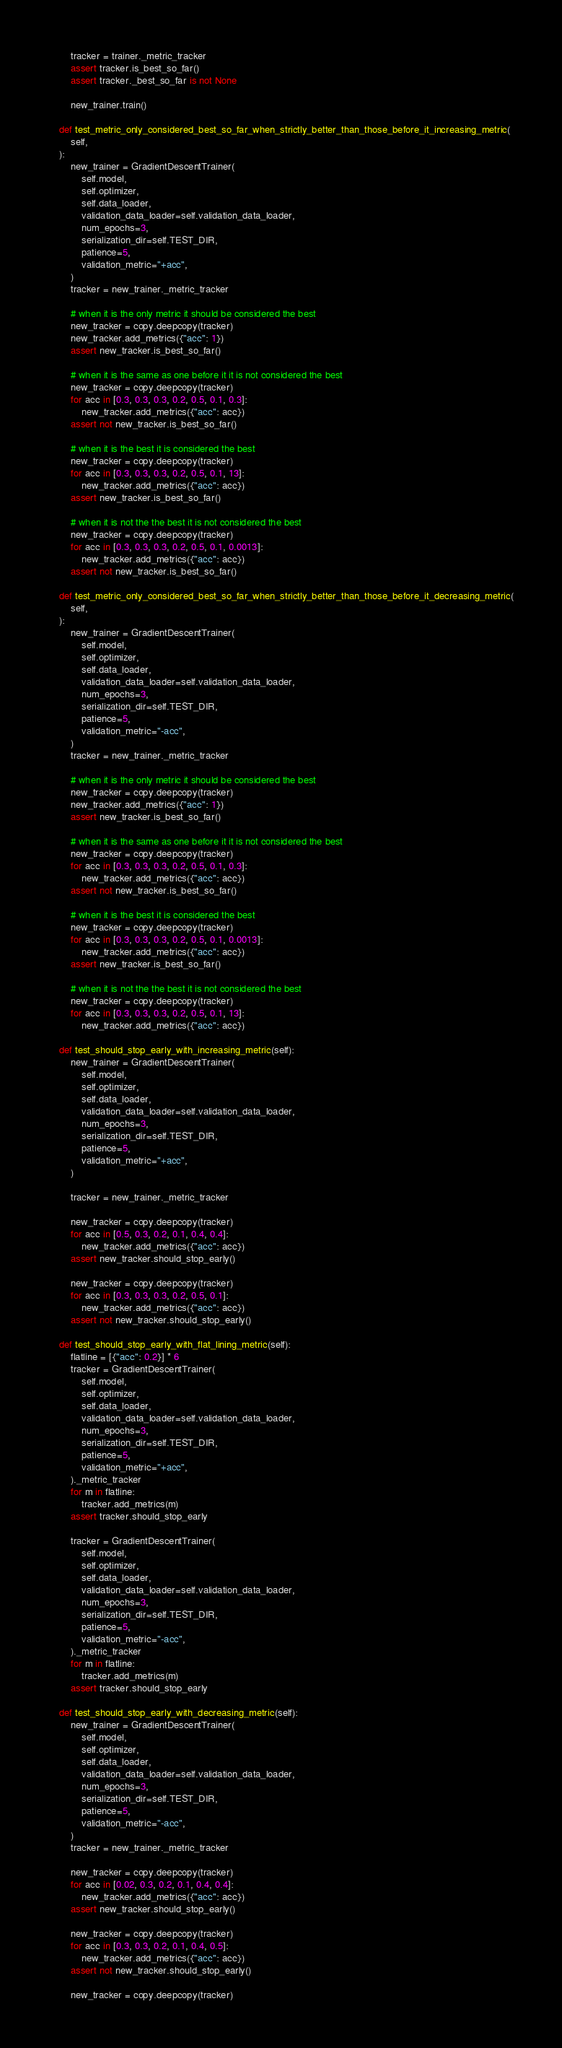Convert code to text. <code><loc_0><loc_0><loc_500><loc_500><_Python_>        tracker = trainer._metric_tracker
        assert tracker.is_best_so_far()
        assert tracker._best_so_far is not None

        new_trainer.train()

    def test_metric_only_considered_best_so_far_when_strictly_better_than_those_before_it_increasing_metric(
        self,
    ):
        new_trainer = GradientDescentTrainer(
            self.model,
            self.optimizer,
            self.data_loader,
            validation_data_loader=self.validation_data_loader,
            num_epochs=3,
            serialization_dir=self.TEST_DIR,
            patience=5,
            validation_metric="+acc",
        )
        tracker = new_trainer._metric_tracker

        # when it is the only metric it should be considered the best
        new_tracker = copy.deepcopy(tracker)
        new_tracker.add_metrics({"acc": 1})
        assert new_tracker.is_best_so_far()

        # when it is the same as one before it it is not considered the best
        new_tracker = copy.deepcopy(tracker)
        for acc in [0.3, 0.3, 0.3, 0.2, 0.5, 0.1, 0.3]:
            new_tracker.add_metrics({"acc": acc})
        assert not new_tracker.is_best_so_far()

        # when it is the best it is considered the best
        new_tracker = copy.deepcopy(tracker)
        for acc in [0.3, 0.3, 0.3, 0.2, 0.5, 0.1, 13]:
            new_tracker.add_metrics({"acc": acc})
        assert new_tracker.is_best_so_far()

        # when it is not the the best it is not considered the best
        new_tracker = copy.deepcopy(tracker)
        for acc in [0.3, 0.3, 0.3, 0.2, 0.5, 0.1, 0.0013]:
            new_tracker.add_metrics({"acc": acc})
        assert not new_tracker.is_best_so_far()

    def test_metric_only_considered_best_so_far_when_strictly_better_than_those_before_it_decreasing_metric(
        self,
    ):
        new_trainer = GradientDescentTrainer(
            self.model,
            self.optimizer,
            self.data_loader,
            validation_data_loader=self.validation_data_loader,
            num_epochs=3,
            serialization_dir=self.TEST_DIR,
            patience=5,
            validation_metric="-acc",
        )
        tracker = new_trainer._metric_tracker

        # when it is the only metric it should be considered the best
        new_tracker = copy.deepcopy(tracker)
        new_tracker.add_metrics({"acc": 1})
        assert new_tracker.is_best_so_far()

        # when it is the same as one before it it is not considered the best
        new_tracker = copy.deepcopy(tracker)
        for acc in [0.3, 0.3, 0.3, 0.2, 0.5, 0.1, 0.3]:
            new_tracker.add_metrics({"acc": acc})
        assert not new_tracker.is_best_so_far()

        # when it is the best it is considered the best
        new_tracker = copy.deepcopy(tracker)
        for acc in [0.3, 0.3, 0.3, 0.2, 0.5, 0.1, 0.0013]:
            new_tracker.add_metrics({"acc": acc})
        assert new_tracker.is_best_so_far()

        # when it is not the the best it is not considered the best
        new_tracker = copy.deepcopy(tracker)
        for acc in [0.3, 0.3, 0.3, 0.2, 0.5, 0.1, 13]:
            new_tracker.add_metrics({"acc": acc})

    def test_should_stop_early_with_increasing_metric(self):
        new_trainer = GradientDescentTrainer(
            self.model,
            self.optimizer,
            self.data_loader,
            validation_data_loader=self.validation_data_loader,
            num_epochs=3,
            serialization_dir=self.TEST_DIR,
            patience=5,
            validation_metric="+acc",
        )

        tracker = new_trainer._metric_tracker

        new_tracker = copy.deepcopy(tracker)
        for acc in [0.5, 0.3, 0.2, 0.1, 0.4, 0.4]:
            new_tracker.add_metrics({"acc": acc})
        assert new_tracker.should_stop_early()

        new_tracker = copy.deepcopy(tracker)
        for acc in [0.3, 0.3, 0.3, 0.2, 0.5, 0.1]:
            new_tracker.add_metrics({"acc": acc})
        assert not new_tracker.should_stop_early()

    def test_should_stop_early_with_flat_lining_metric(self):
        flatline = [{"acc": 0.2}] * 6
        tracker = GradientDescentTrainer(
            self.model,
            self.optimizer,
            self.data_loader,
            validation_data_loader=self.validation_data_loader,
            num_epochs=3,
            serialization_dir=self.TEST_DIR,
            patience=5,
            validation_metric="+acc",
        )._metric_tracker
        for m in flatline:
            tracker.add_metrics(m)
        assert tracker.should_stop_early

        tracker = GradientDescentTrainer(
            self.model,
            self.optimizer,
            self.data_loader,
            validation_data_loader=self.validation_data_loader,
            num_epochs=3,
            serialization_dir=self.TEST_DIR,
            patience=5,
            validation_metric="-acc",
        )._metric_tracker
        for m in flatline:
            tracker.add_metrics(m)
        assert tracker.should_stop_early

    def test_should_stop_early_with_decreasing_metric(self):
        new_trainer = GradientDescentTrainer(
            self.model,
            self.optimizer,
            self.data_loader,
            validation_data_loader=self.validation_data_loader,
            num_epochs=3,
            serialization_dir=self.TEST_DIR,
            patience=5,
            validation_metric="-acc",
        )
        tracker = new_trainer._metric_tracker

        new_tracker = copy.deepcopy(tracker)
        for acc in [0.02, 0.3, 0.2, 0.1, 0.4, 0.4]:
            new_tracker.add_metrics({"acc": acc})
        assert new_tracker.should_stop_early()

        new_tracker = copy.deepcopy(tracker)
        for acc in [0.3, 0.3, 0.2, 0.1, 0.4, 0.5]:
            new_tracker.add_metrics({"acc": acc})
        assert not new_tracker.should_stop_early()

        new_tracker = copy.deepcopy(tracker)</code> 